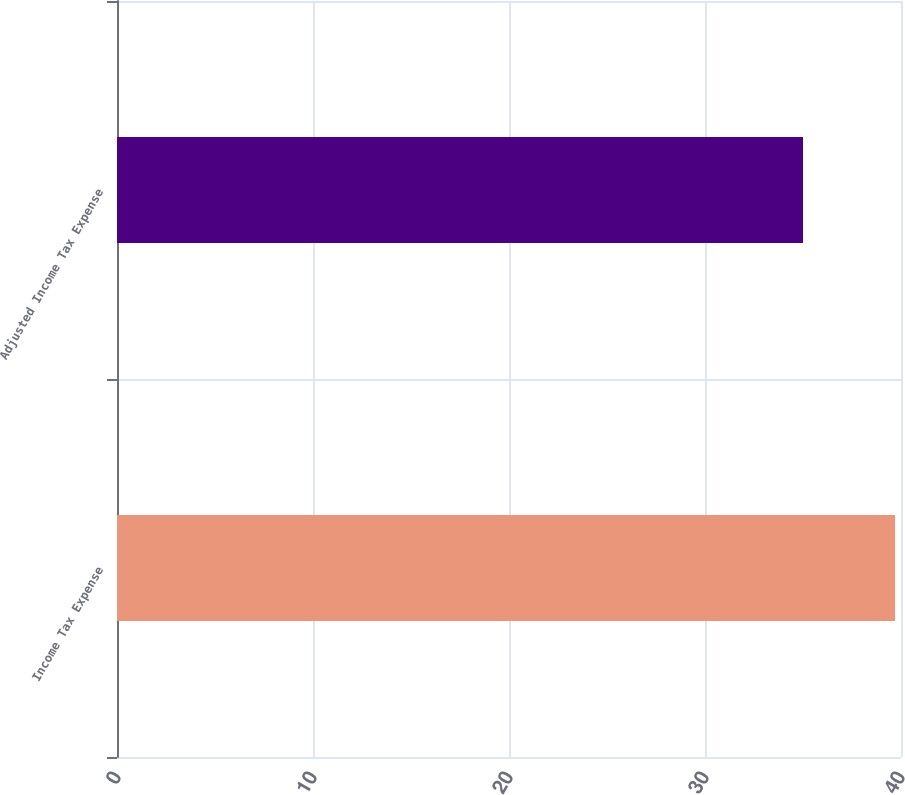<chart> <loc_0><loc_0><loc_500><loc_500><bar_chart><fcel>Income Tax Expense<fcel>Adjusted Income Tax Expense<nl><fcel>39.7<fcel>35<nl></chart> 